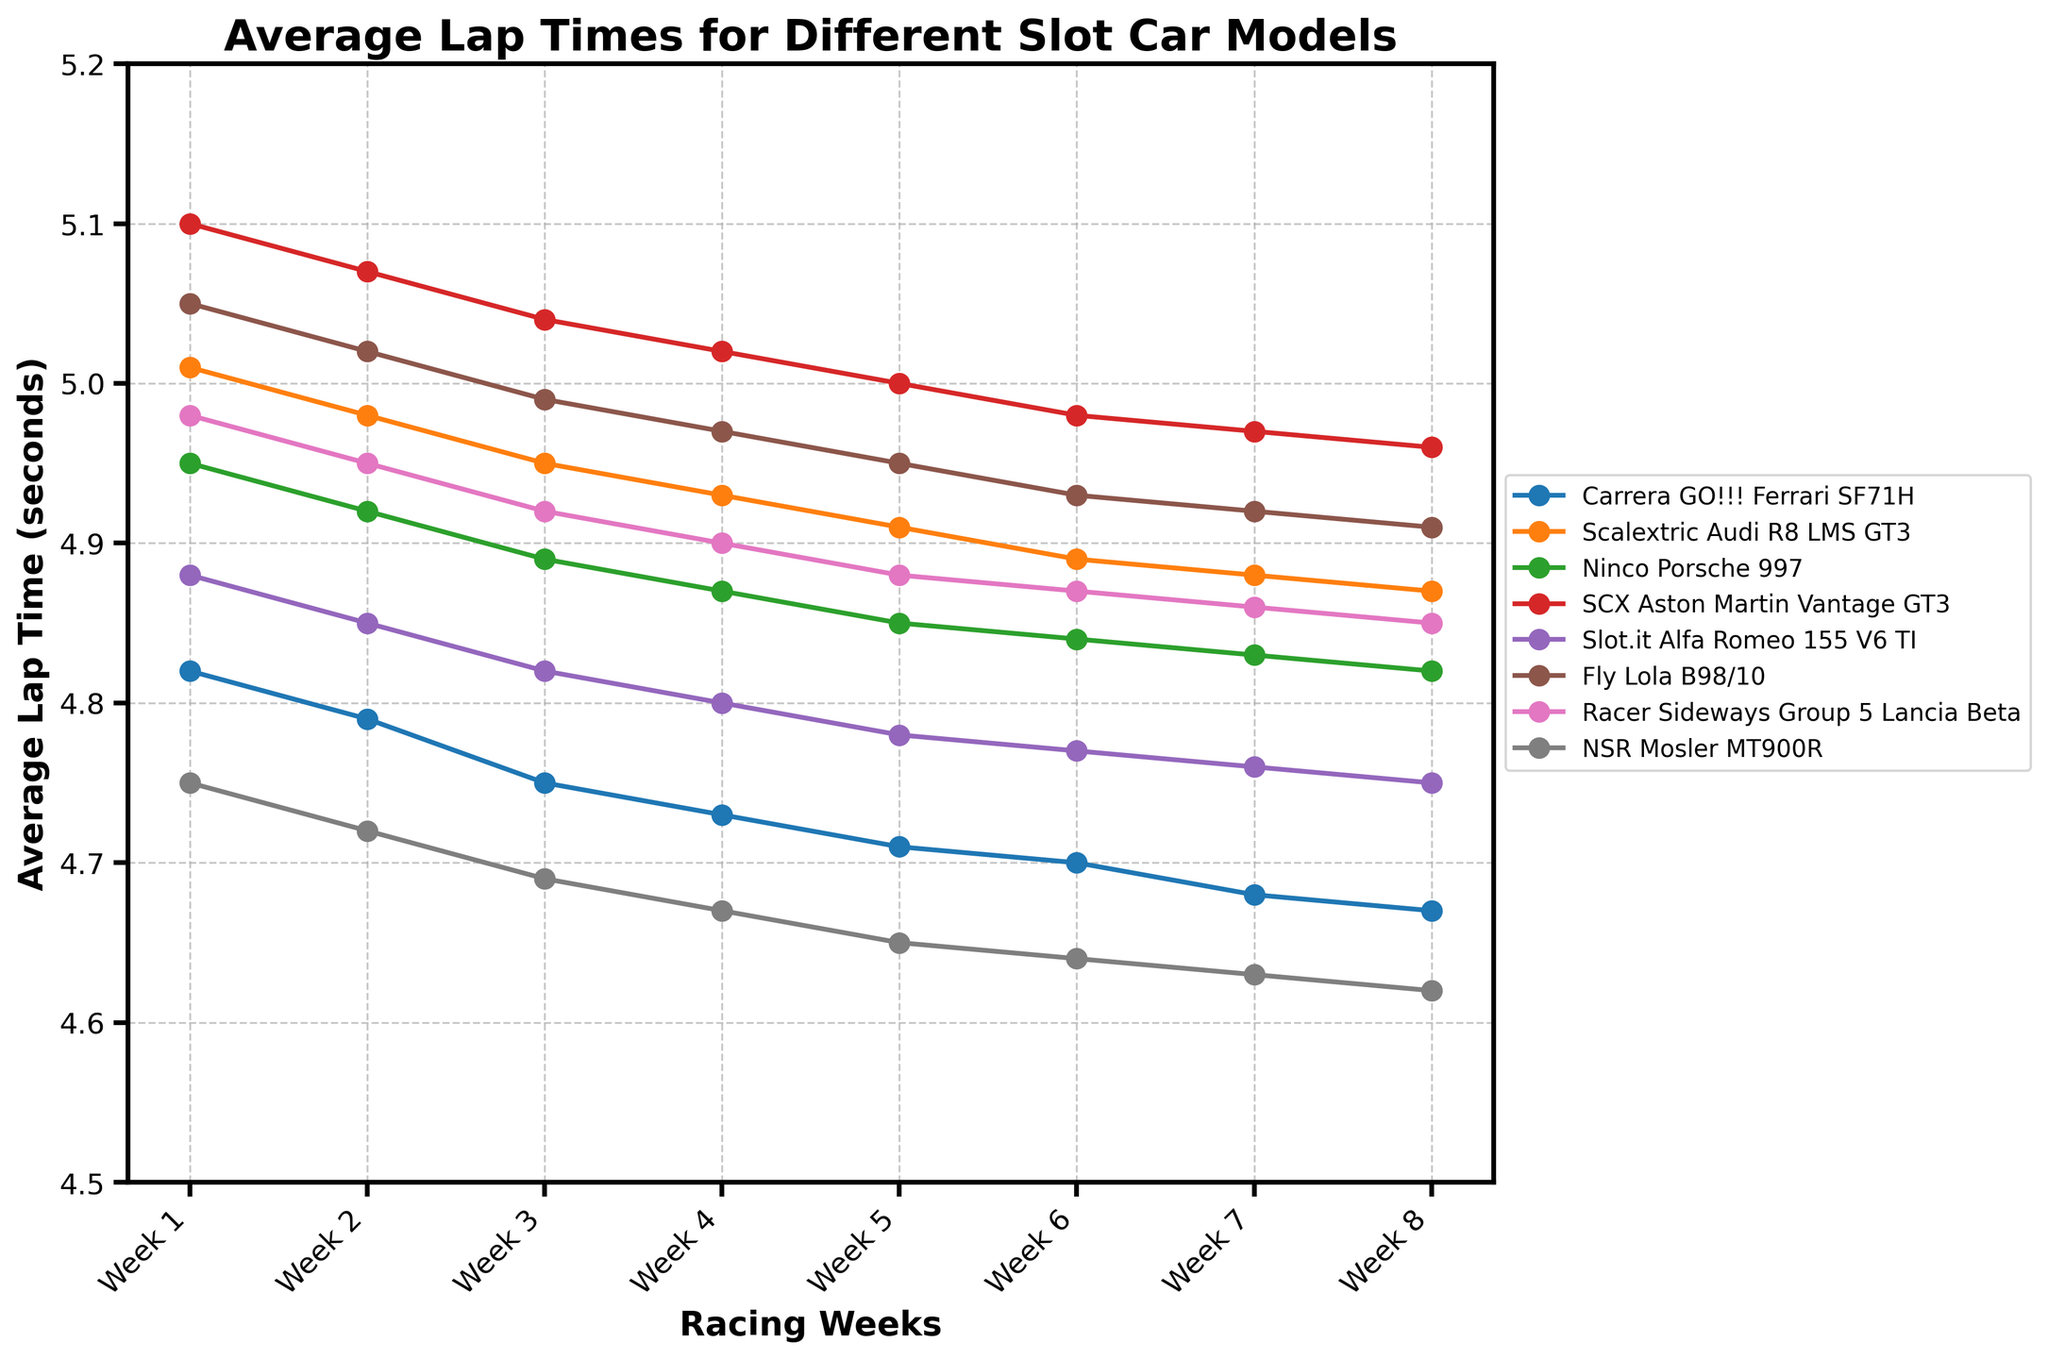1. Which slot car model shows the fastest average lap time in Week 8? To determine the fastest average lap time in Week 8, look for the lowest value in the Week 8 column. The NSR Mosler MT900R has the lowest lap time of 4.62 seconds.
Answer: NSR Mosler MT900R 2. How much did the average lap time improve for the Carrera GO!!! Ferrari SF71H from Week 1 to Week 8? Subtract the average lap time in Week 8 from the time in Week 1 for the Carrera GO!!! Ferrari SF71H: 4.82 - 4.67 = 0.15 seconds.
Answer: 0.15 seconds 3. Which two slot car models have the closest average lap times in Week 5? Compare the values in the Week 5 column to find the two closest times. Both the Carrera GO!!! Ferrari SF71H and Slot.it Alfa Romeo 155 V6 TI have times close to the NSR Mosler MT900R. The nearest pair is the Carrera GO!!! Ferrari SF71H (4.71) and Slot.it Alfa Romeo 155 V6 TI (4.78) with a difference of 0.07 seconds.
Answer: Carrera GO!!! Ferrari SF71H and Slot.it Alfa Romeo 155 V6 TI 4. Over the entire season, which slot car model had the largest reduction in average lap time? Calculate the difference between Week 1 and Week 8 average lap times for all models and find the largest reduction. The NSR Mosler MT900R reduced its lap time from 4.75 to 4.62 seconds, a reduction of 0.13 seconds.
Answer: NSR Mosler MT900R 5. In which week do all slot car models have their best (i.e., lowest) average lap times? Check each week to see where most models have their lowest average lap times. Week 8 generally has the lowest times for all models.
Answer: Week 8 6. Compare the performance of Ninco Porsche 997 and Scalextric Audi R8 LMS GT3. Which one had a more consistent lap time improvement each week? Calculate the difference in lap times week by week for both models and compare the stability. The Ninco Porsche 997 has slightly more constant improvements (0.03, 0.03, 0.02, 0.02, 0.01, 0.01, 0.01) compared to the Scalextric Audi R8 LMS GT3 (0.03, 0.03, 0.02, 0.02, 0.02, 0.01, 0.01).
Answer: Ninco Porsche 997 7. Which model has the steepest decline in average lap times from Week 1 to Week 2? Find the average lap time difference between Week 1 and Week 2 for all models and determine which has the largest drop. The NSR Mosler MT900R shows a decrease from 4.75 to 4.72 or a decline of 0.03 seconds.
Answer: NSR Mosler MT900R 8. Rank the top three models by their average lap time in Week 4. Write down the Week 4 lap times and order them from lowest to highest. The top three models are NSR Mosler MT900R (4.67), Carrera GO!!! Ferrari SF71H (4.73), and Slot.it Alfa Romeo 155 V6 TI (4.80).
Answer: NSR Mosler MT900R, Carrera GO!!! Ferrari SF71H, Slot.it Alfa Romeo 155 V6 TI 